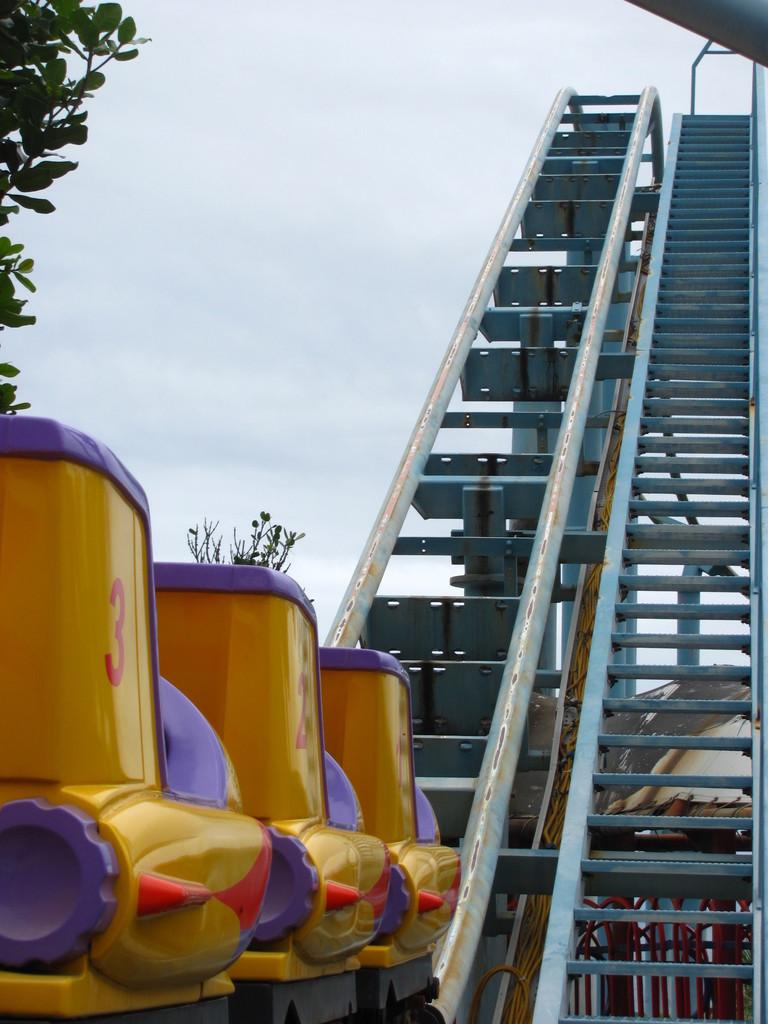What is the main subject of the image? There is a roller coaster in the image. What can be seen in the background of the image? There are trees and the sky visible in the background of the image. What type of animal can be seen distributing flyers near the roller coaster in the image? There is no animal or flyers present in the image; it only features a roller coaster and the background. 